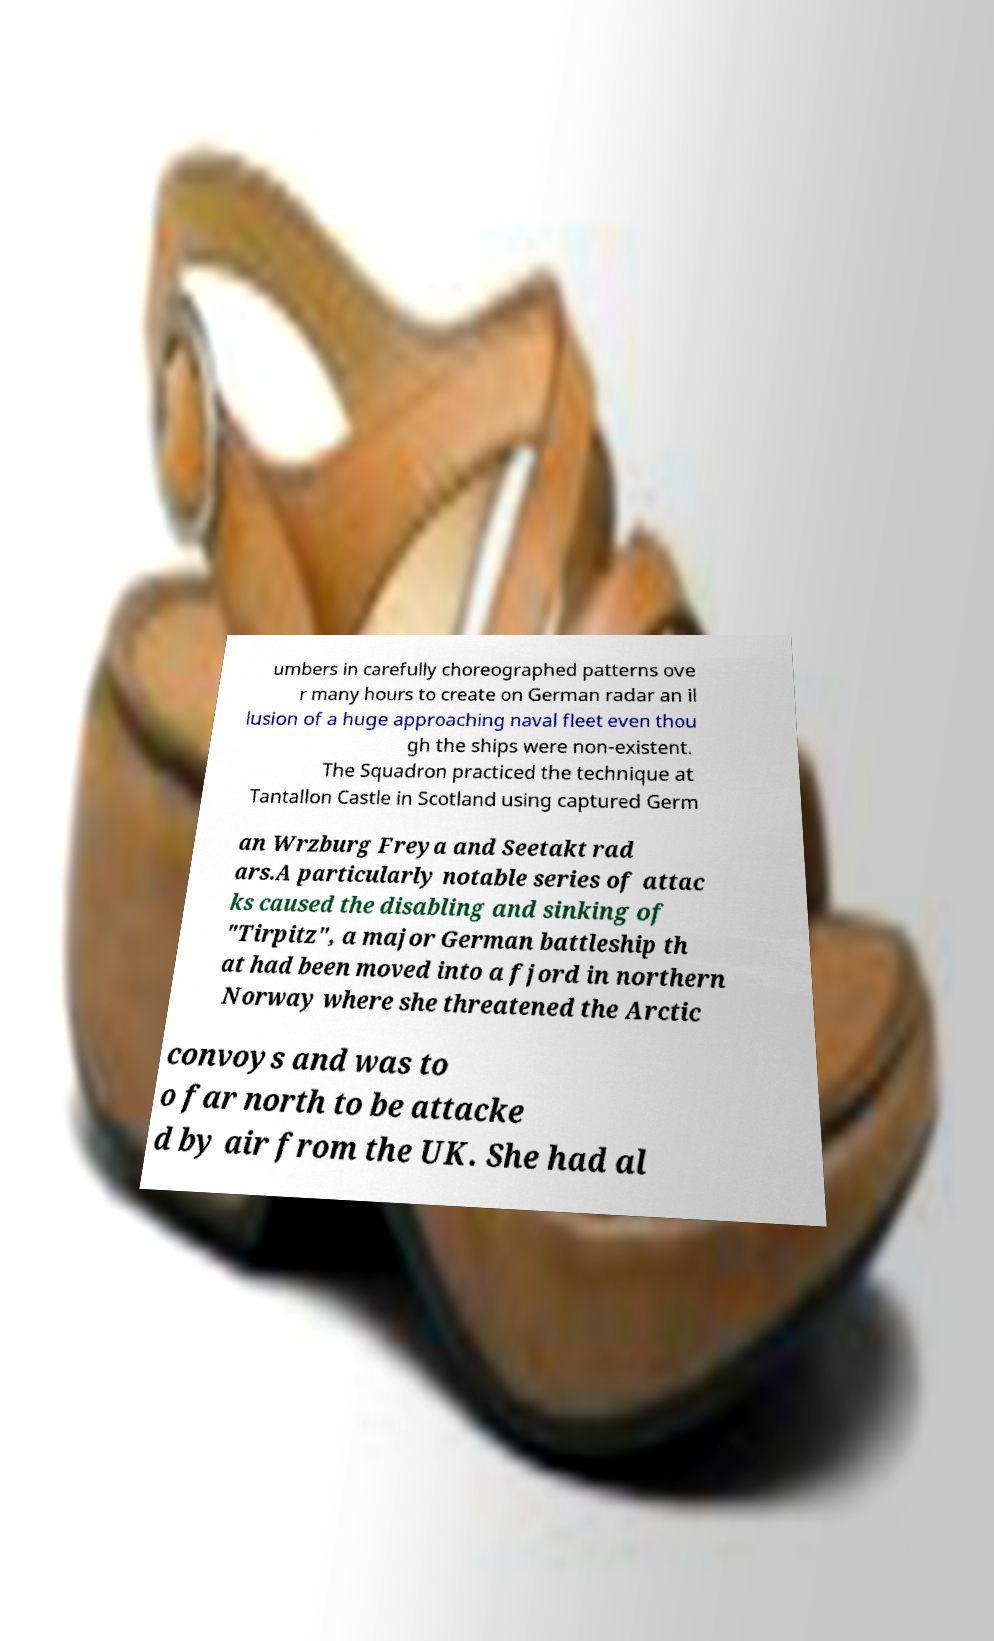Please read and relay the text visible in this image. What does it say? umbers in carefully choreographed patterns ove r many hours to create on German radar an il lusion of a huge approaching naval fleet even thou gh the ships were non-existent. The Squadron practiced the technique at Tantallon Castle in Scotland using captured Germ an Wrzburg Freya and Seetakt rad ars.A particularly notable series of attac ks caused the disabling and sinking of "Tirpitz", a major German battleship th at had been moved into a fjord in northern Norway where she threatened the Arctic convoys and was to o far north to be attacke d by air from the UK. She had al 